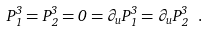<formula> <loc_0><loc_0><loc_500><loc_500>P ^ { 3 } _ { 1 } = P ^ { 3 } _ { 2 } = 0 = \partial _ { u } P ^ { 3 } _ { 1 } = \partial _ { u } P ^ { 3 } _ { 2 } \ .</formula> 